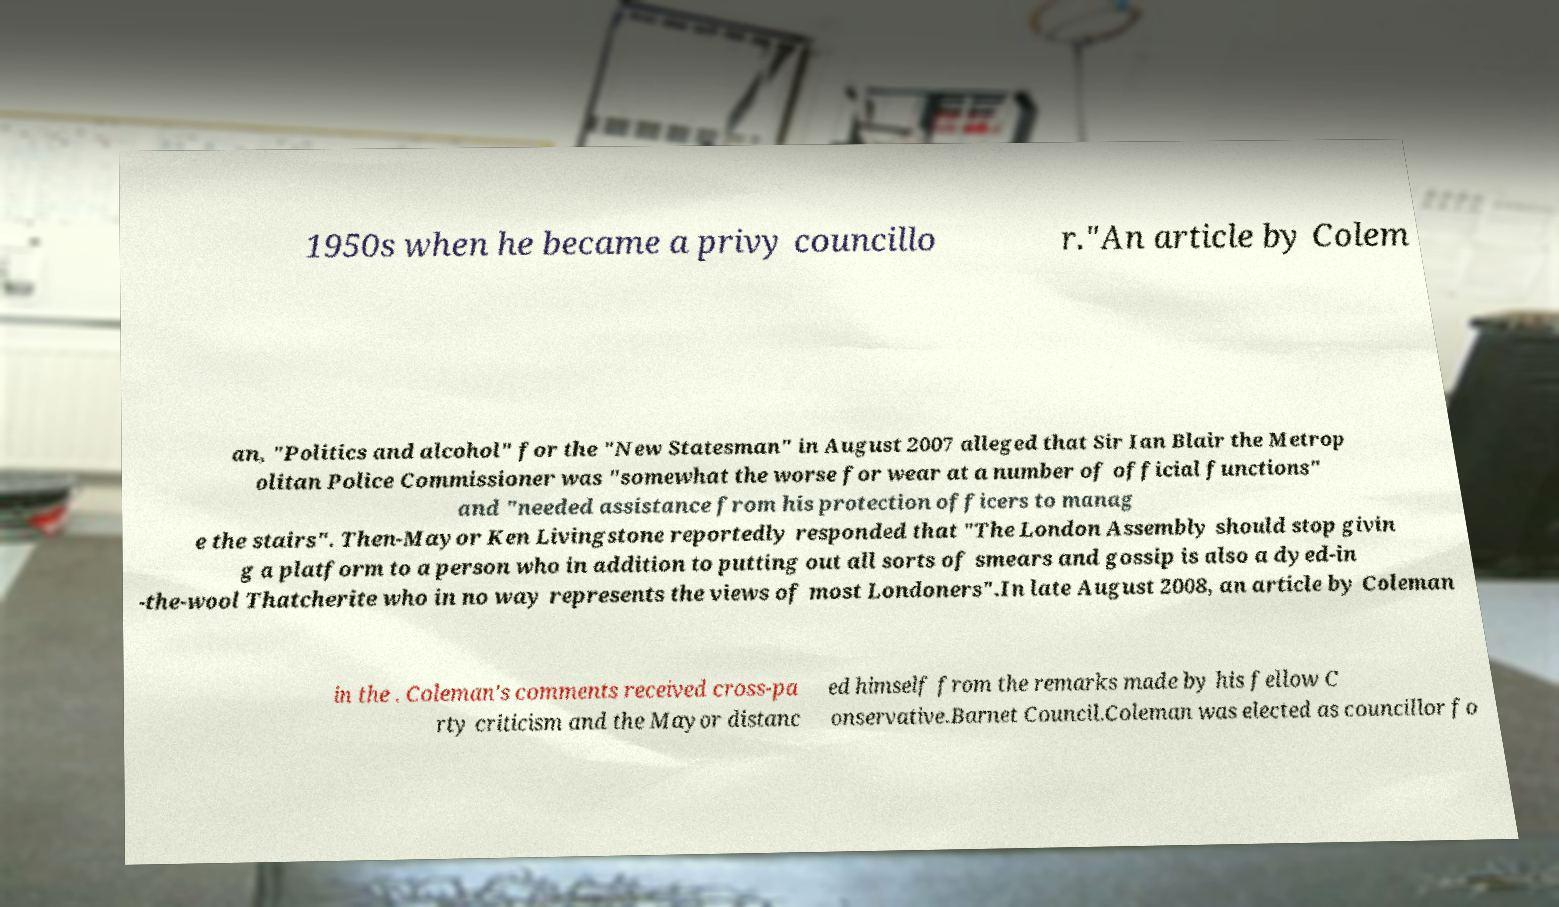Please identify and transcribe the text found in this image. 1950s when he became a privy councillo r."An article by Colem an, "Politics and alcohol" for the "New Statesman" in August 2007 alleged that Sir Ian Blair the Metrop olitan Police Commissioner was "somewhat the worse for wear at a number of official functions" and "needed assistance from his protection officers to manag e the stairs". Then-Mayor Ken Livingstone reportedly responded that "The London Assembly should stop givin g a platform to a person who in addition to putting out all sorts of smears and gossip is also a dyed-in -the-wool Thatcherite who in no way represents the views of most Londoners".In late August 2008, an article by Coleman in the . Coleman's comments received cross-pa rty criticism and the Mayor distanc ed himself from the remarks made by his fellow C onservative.Barnet Council.Coleman was elected as councillor fo 